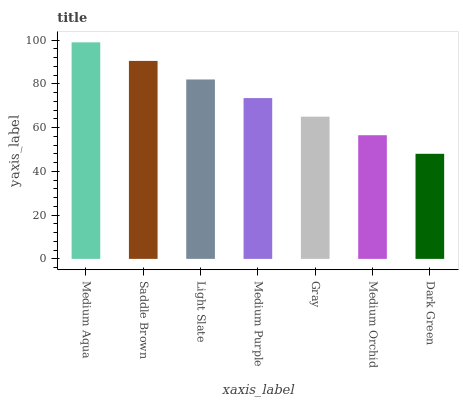Is Dark Green the minimum?
Answer yes or no. Yes. Is Medium Aqua the maximum?
Answer yes or no. Yes. Is Saddle Brown the minimum?
Answer yes or no. No. Is Saddle Brown the maximum?
Answer yes or no. No. Is Medium Aqua greater than Saddle Brown?
Answer yes or no. Yes. Is Saddle Brown less than Medium Aqua?
Answer yes or no. Yes. Is Saddle Brown greater than Medium Aqua?
Answer yes or no. No. Is Medium Aqua less than Saddle Brown?
Answer yes or no. No. Is Medium Purple the high median?
Answer yes or no. Yes. Is Medium Purple the low median?
Answer yes or no. Yes. Is Light Slate the high median?
Answer yes or no. No. Is Light Slate the low median?
Answer yes or no. No. 